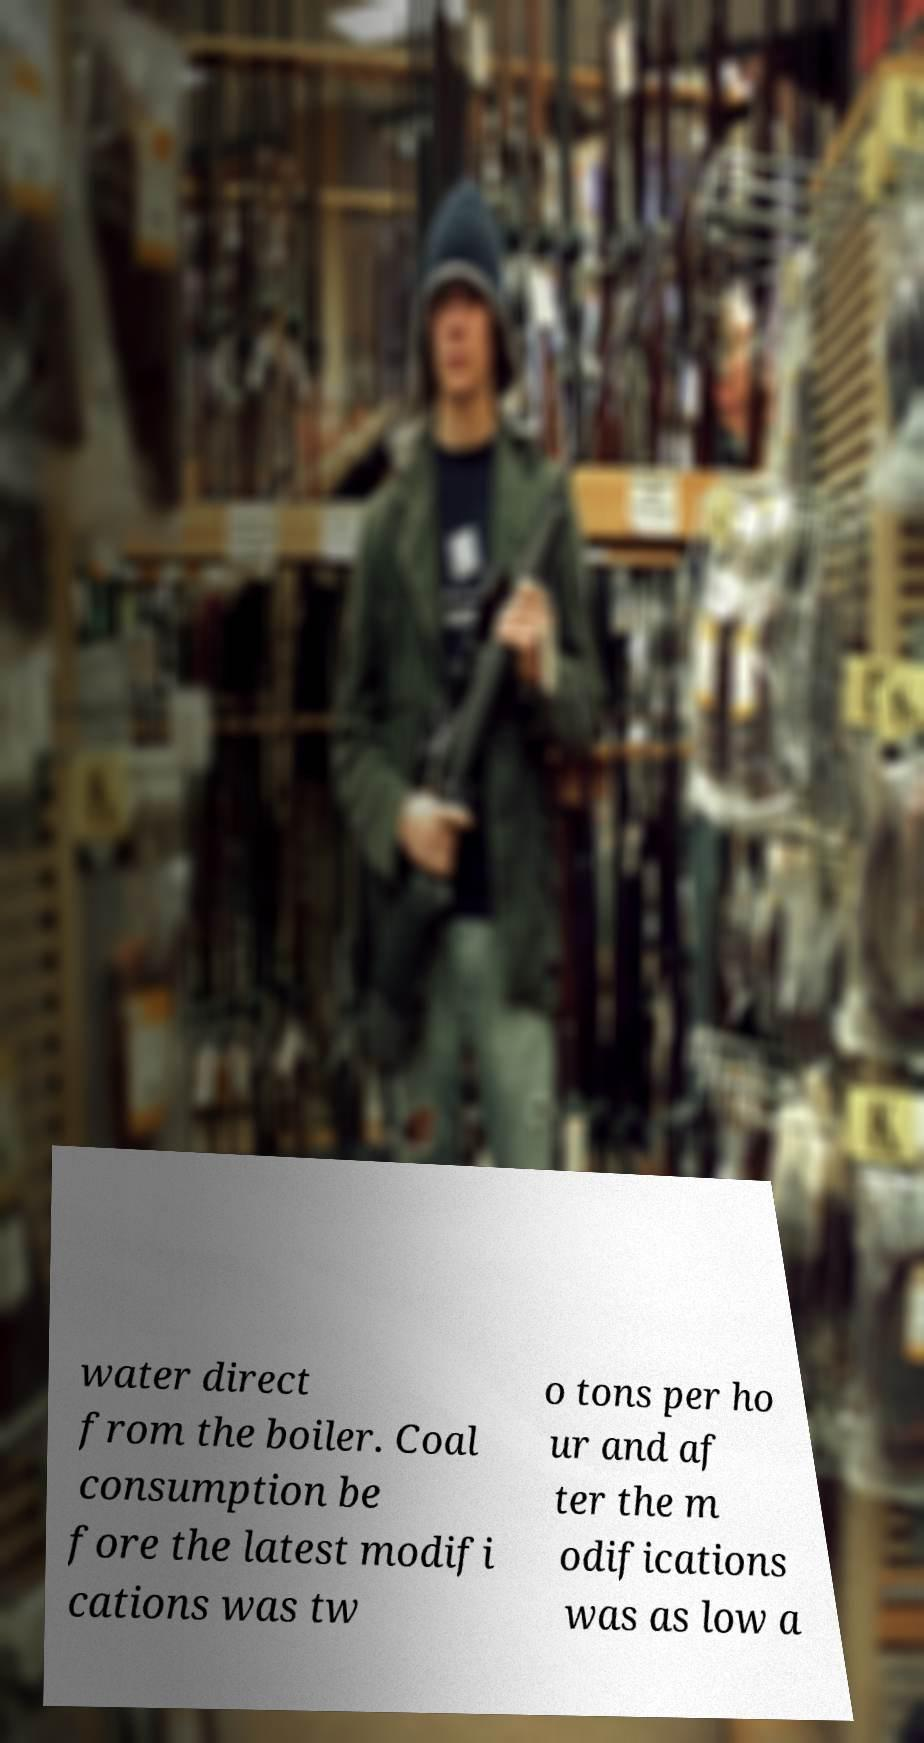What messages or text are displayed in this image? I need them in a readable, typed format. water direct from the boiler. Coal consumption be fore the latest modifi cations was tw o tons per ho ur and af ter the m odifications was as low a 